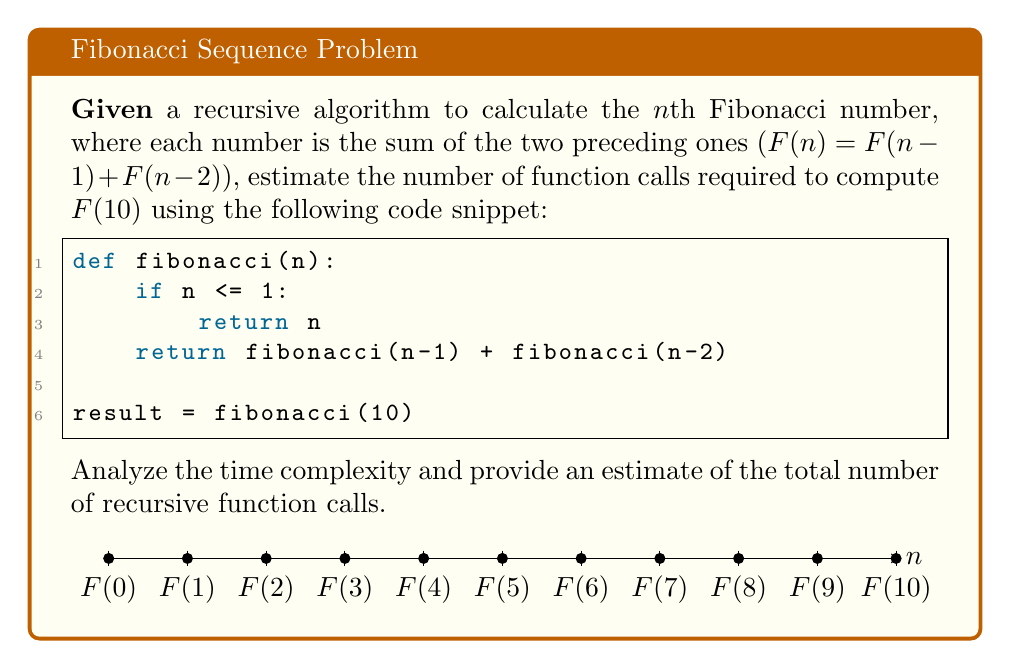What is the answer to this math problem? To estimate the number of function calls, let's analyze the recursive structure:

1) First, observe that each call to fibonacci(n) makes two recursive calls for n > 1.

2) The recursion tree for F(10) will have a depth of 10, and each node (except leaf nodes) will have two children.

3) This forms a binary tree-like structure, where the number of nodes roughly doubles at each level.

4) The time complexity of this naive recursive implementation is approximately $O(2^n)$.

5) To estimate the total number of function calls, we can use the formula for the sum of a geometric series:

   $$S_n = \frac{a(1-r^n)}{1-r}$$

   Where a = 1 (starting with one call), r = 2 (doubling at each level), and n = 10 (depth of the tree).

6) Plugging in the values:

   $$S_{10} = \frac{1(1-2^{10})}{1-2} = 2^{10} - 1 = 1023$$

7) This gives us a lower bound. The actual number will be slightly higher due to overlapping subproblems.

8) A more precise estimate can be obtained using the closed-form expression for Fibonacci numbers:

   $$F_n = \frac{\phi^n - (-\phi)^{-n}}{\sqrt{5}}$$

   Where $\phi = \frac{1+\sqrt{5}}{2}$ is the golden ratio.

9) The number of function calls is approximately proportional to $\phi^n$.

10) For n = 10, this gives us: $\phi^{10} \approx 123$.

11) Multiplying this by a small constant factor (around 1.5 to 2) to account for the actual implementation details, we get an estimate between 185 and 246 function calls.
Answer: Approximately 200 function calls 